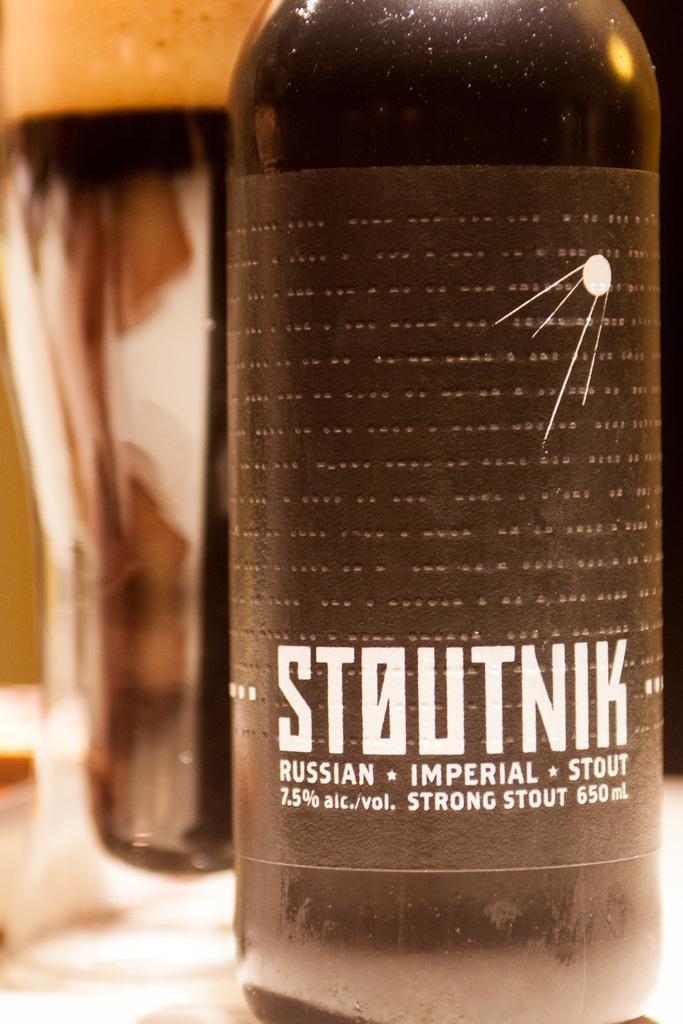Describe this image in one or two sentences. In this picture there is a bottle and there is a text on the label. At the back there is a glass and there is a wall. 